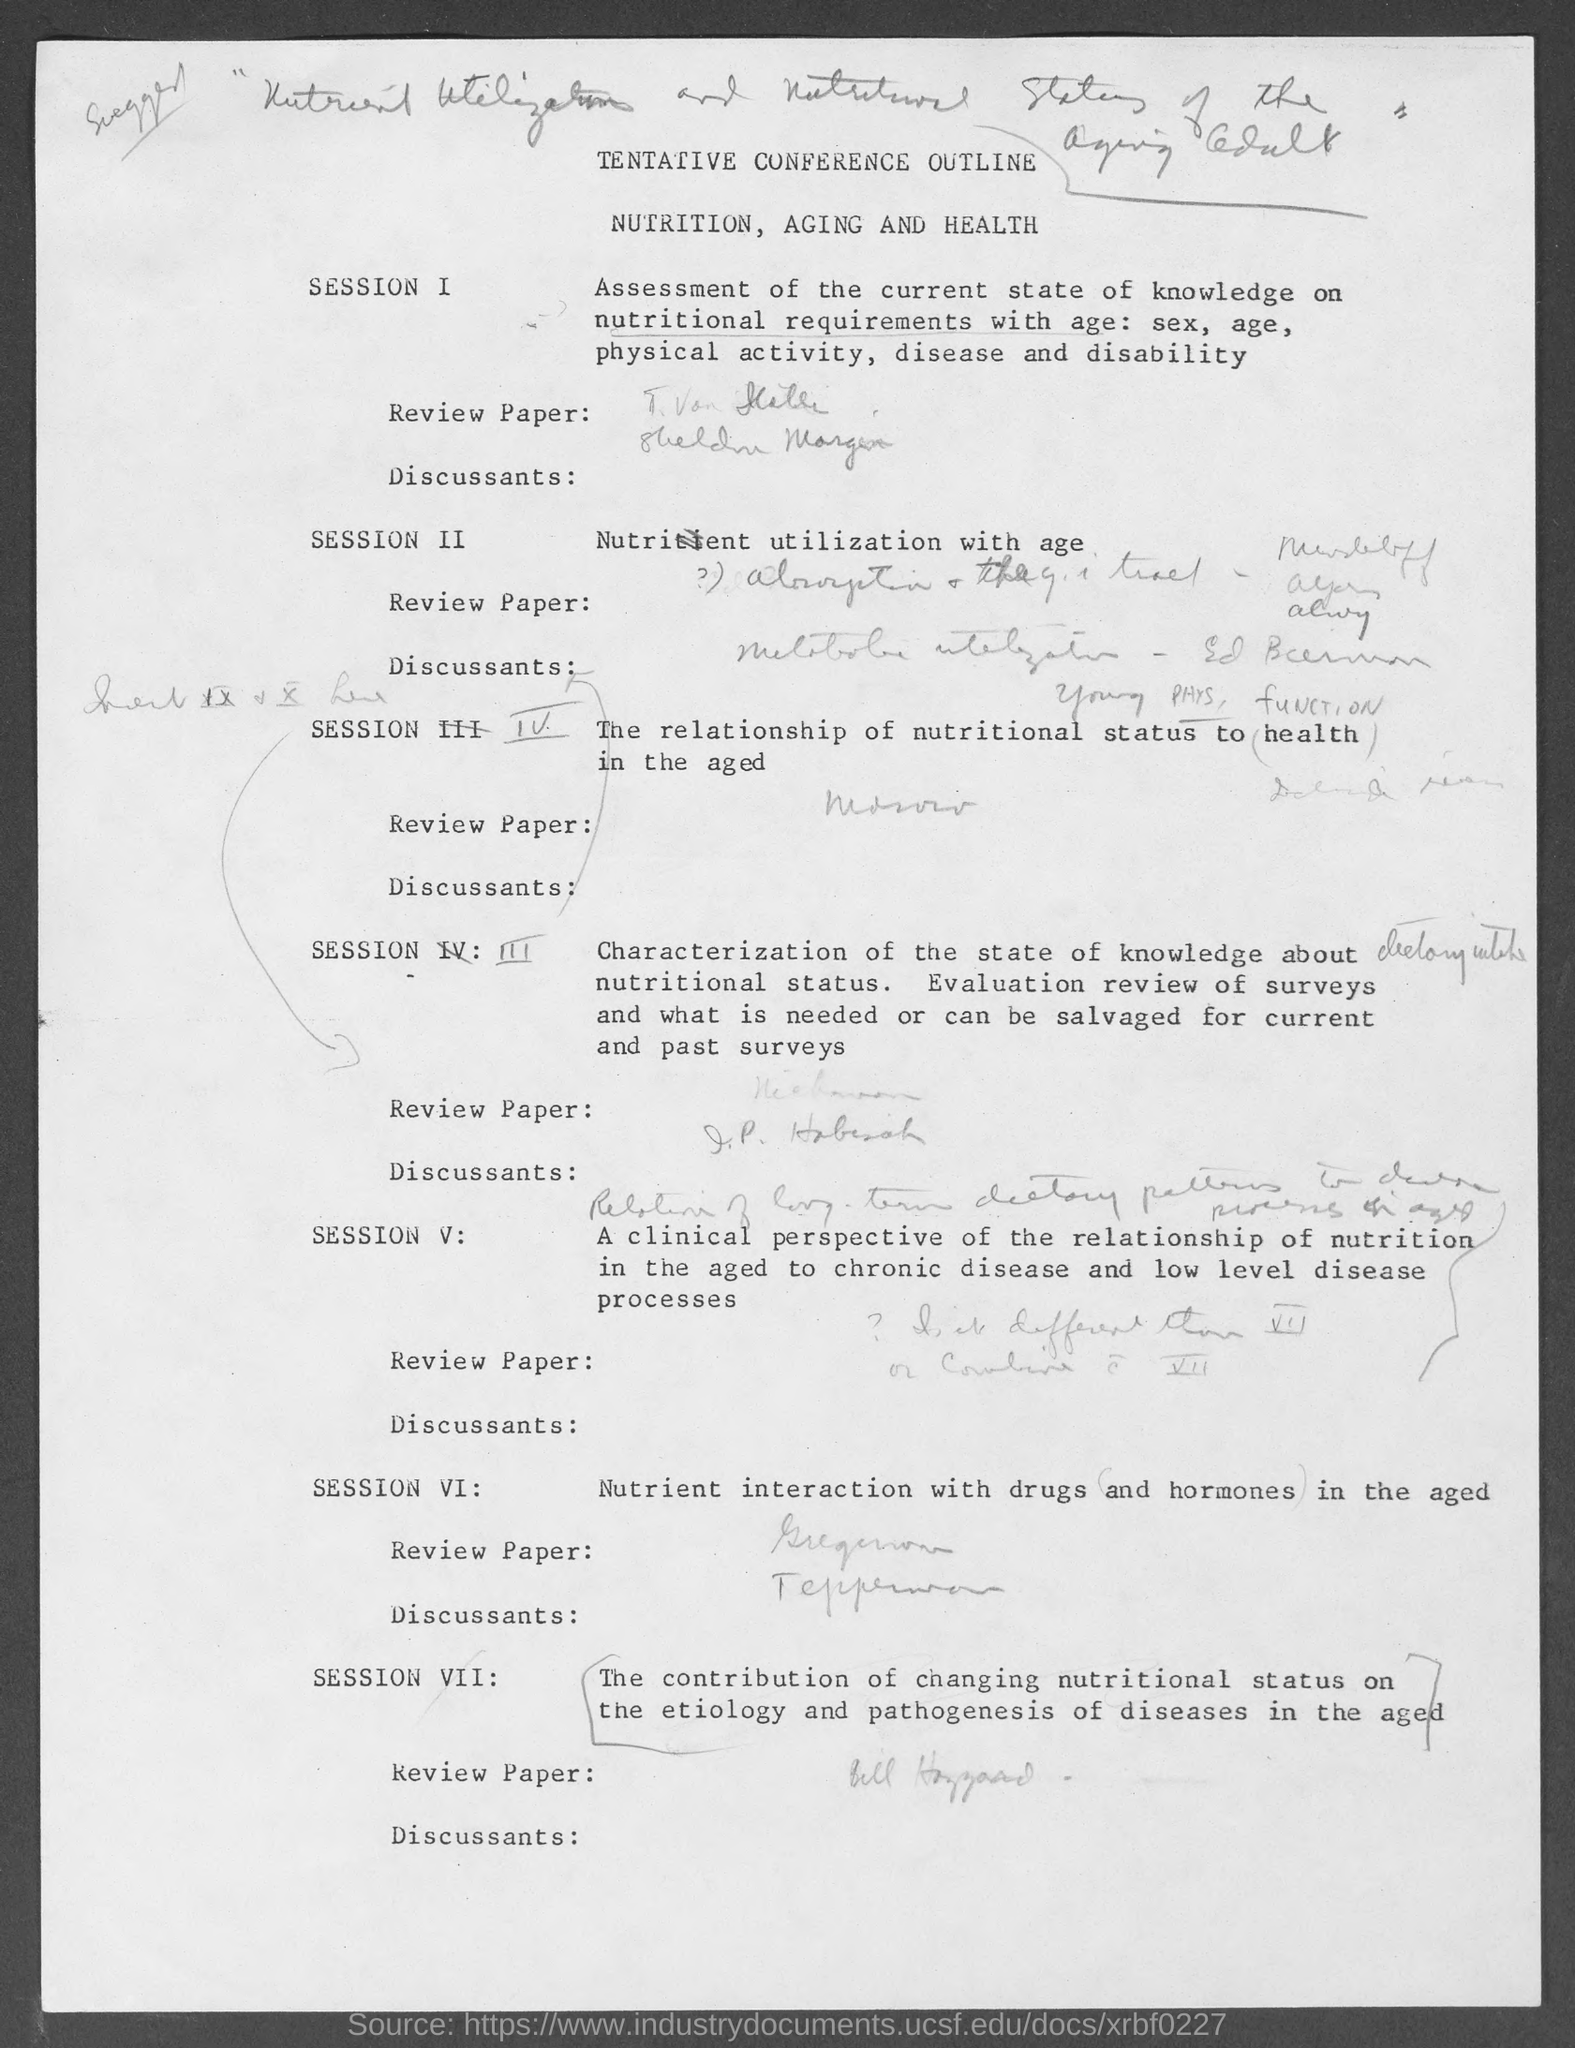Specify some key components in this picture. Session II will focus on the topic of nutrient utilization with age, covering various aspects of how nutrient requirements change with age and how different populations may have unique needs based on their age and stage of life. 